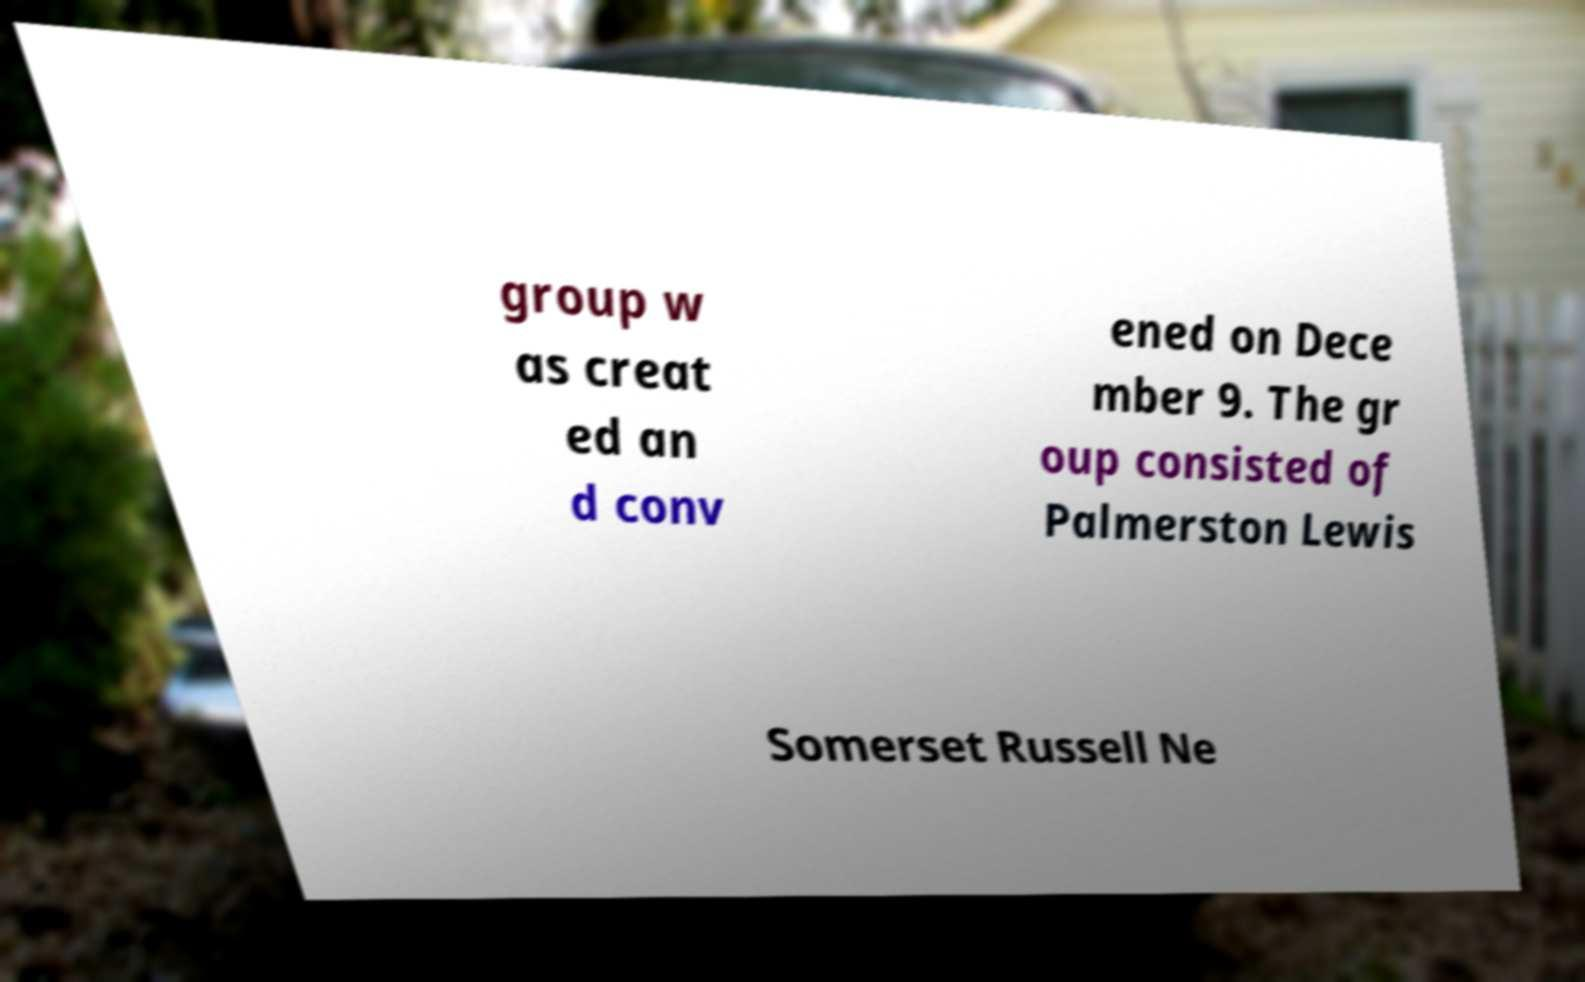For documentation purposes, I need the text within this image transcribed. Could you provide that? group w as creat ed an d conv ened on Dece mber 9. The gr oup consisted of Palmerston Lewis Somerset Russell Ne 